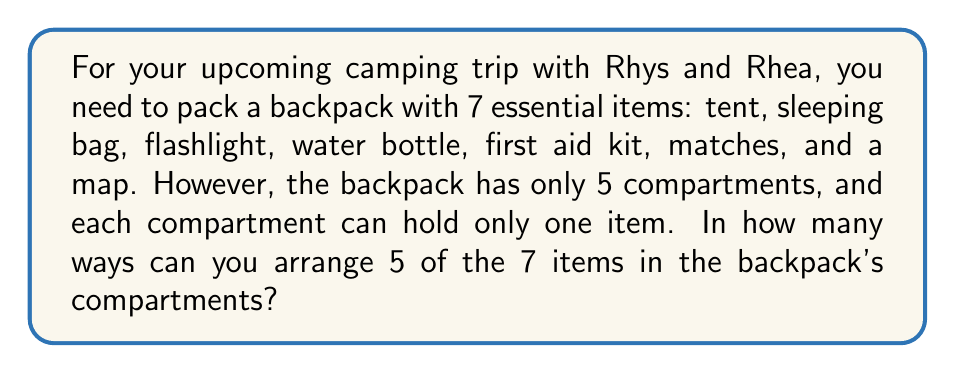Can you solve this math problem? To solve this problem, we need to use the concept of permutations. Here's the step-by-step solution:

1) First, we need to choose 5 items out of the 7 available items. This is a combination problem.
   The number of ways to choose 5 items out of 7 is denoted as $\binom{7}{5}$ or $C(7,5)$.

   $$\binom{7}{5} = \frac{7!}{5!(7-5)!} = \frac{7!}{5!2!}$$

2) After selecting 5 items, we need to arrange them in the 5 compartments. This is a permutation of 5 items, which is simply 5!.

3) By the multiplication principle, the total number of ways to arrange the camping gear is:

   $$\binom{7}{5} \times 5!$$

4) Let's calculate:
   
   $$\binom{7}{5} = \frac{7!}{5!2!} = \frac{7 \times 6}{2 \times 1} = 21$$

5) Now, we multiply this by 5!:

   $$21 \times 5! = 21 \times (5 \times 4 \times 3 \times 2 \times 1) = 21 \times 120 = 2520$$

Therefore, there are 2520 ways to arrange 5 of the 7 camping items in the backpack's 5 compartments.
Answer: 2520 ways 